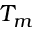<formula> <loc_0><loc_0><loc_500><loc_500>T _ { m }</formula> 